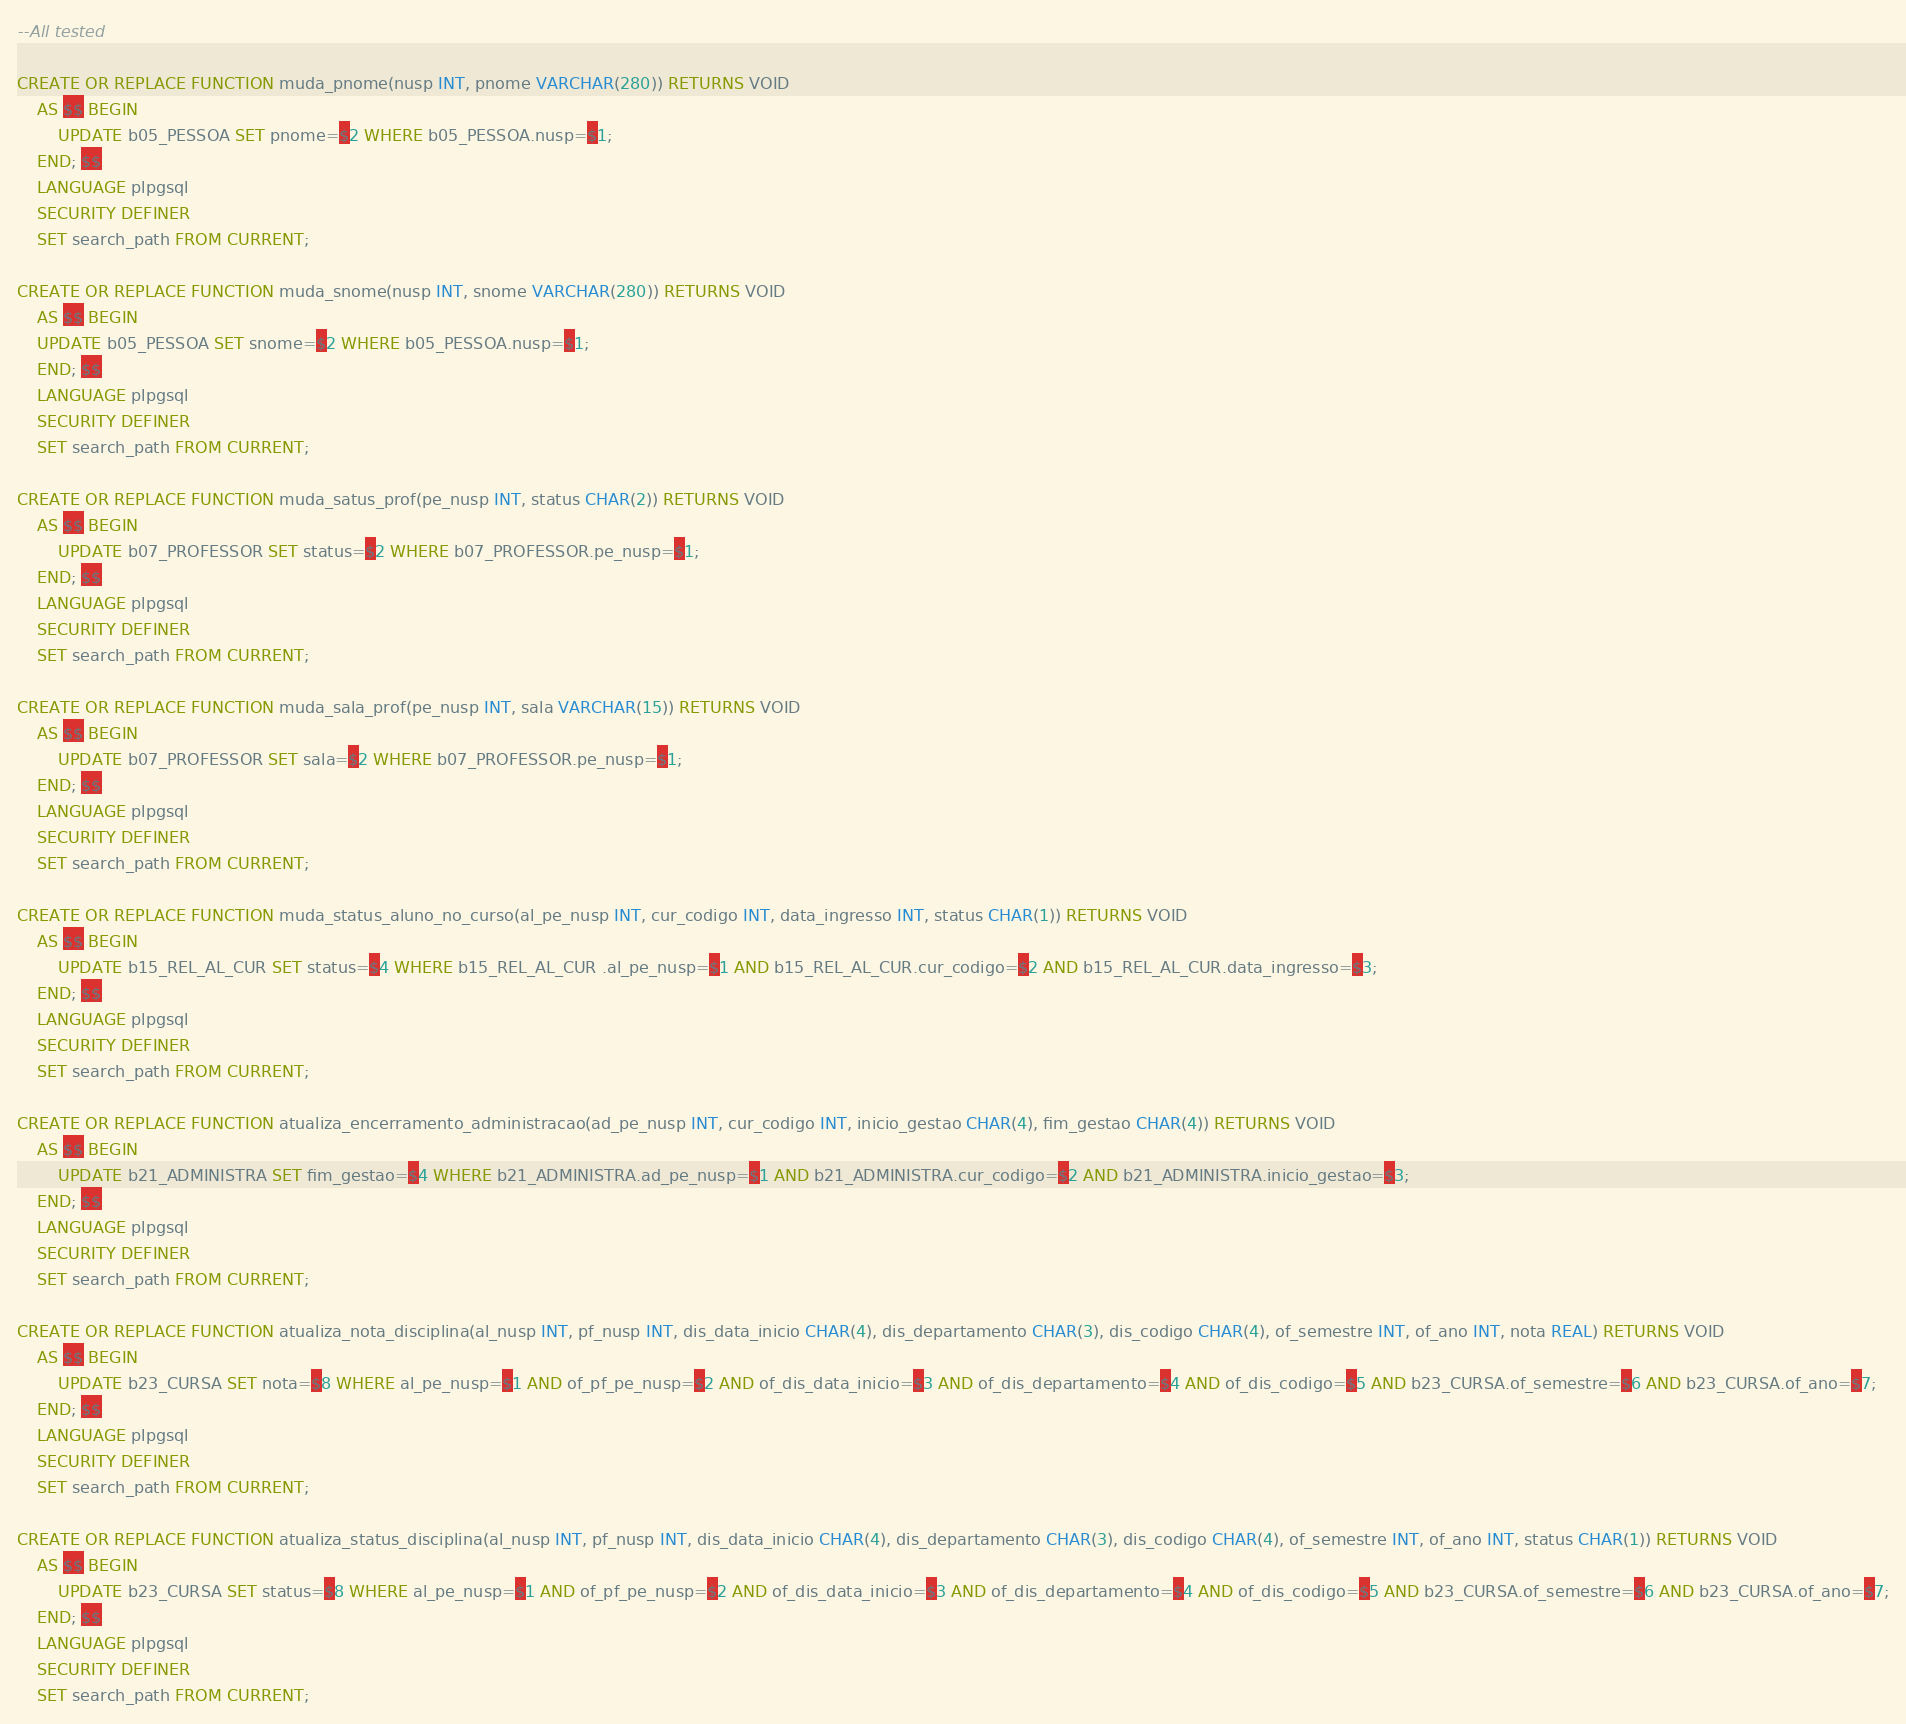Convert code to text. <code><loc_0><loc_0><loc_500><loc_500><_SQL_>--All tested

CREATE OR REPLACE FUNCTION muda_pnome(nusp INT, pnome VARCHAR(280)) RETURNS VOID
    AS $$ BEGIN
        UPDATE b05_PESSOA SET pnome=$2 WHERE b05_PESSOA.nusp=$1;
    END; $$
    LANGUAGE plpgsql
    SECURITY DEFINER
    SET search_path FROM CURRENT;

CREATE OR REPLACE FUNCTION muda_snome(nusp INT, snome VARCHAR(280)) RETURNS VOID
    AS $$ BEGIN
    UPDATE b05_PESSOA SET snome=$2 WHERE b05_PESSOA.nusp=$1;
    END; $$
    LANGUAGE plpgsql
    SECURITY DEFINER
    SET search_path FROM CURRENT;

CREATE OR REPLACE FUNCTION muda_satus_prof(pe_nusp INT, status CHAR(2)) RETURNS VOID
    AS $$ BEGIN
        UPDATE b07_PROFESSOR SET status=$2 WHERE b07_PROFESSOR.pe_nusp=$1;
    END; $$
    LANGUAGE plpgsql
    SECURITY DEFINER
    SET search_path FROM CURRENT;

CREATE OR REPLACE FUNCTION muda_sala_prof(pe_nusp INT, sala VARCHAR(15)) RETURNS VOID
    AS $$ BEGIN
        UPDATE b07_PROFESSOR SET sala=$2 WHERE b07_PROFESSOR.pe_nusp=$1;
    END; $$
    LANGUAGE plpgsql
    SECURITY DEFINER
    SET search_path FROM CURRENT;

CREATE OR REPLACE FUNCTION muda_status_aluno_no_curso(al_pe_nusp INT, cur_codigo INT, data_ingresso INT, status CHAR(1)) RETURNS VOID
    AS $$ BEGIN
        UPDATE b15_REL_AL_CUR SET status=$4 WHERE b15_REL_AL_CUR .al_pe_nusp=$1 AND b15_REL_AL_CUR.cur_codigo=$2 AND b15_REL_AL_CUR.data_ingresso=$3;
    END; $$
    LANGUAGE plpgsql
    SECURITY DEFINER
    SET search_path FROM CURRENT;

CREATE OR REPLACE FUNCTION atualiza_encerramento_administracao(ad_pe_nusp INT, cur_codigo INT, inicio_gestao CHAR(4), fim_gestao CHAR(4)) RETURNS VOID
    AS $$ BEGIN
        UPDATE b21_ADMINISTRA SET fim_gestao=$4 WHERE b21_ADMINISTRA.ad_pe_nusp=$1 AND b21_ADMINISTRA.cur_codigo=$2 AND b21_ADMINISTRA.inicio_gestao=$3;
    END; $$
    LANGUAGE plpgsql
    SECURITY DEFINER
    SET search_path FROM CURRENT;

CREATE OR REPLACE FUNCTION atualiza_nota_disciplina(al_nusp INT, pf_nusp INT, dis_data_inicio CHAR(4), dis_departamento CHAR(3), dis_codigo CHAR(4), of_semestre INT, of_ano INT, nota REAL) RETURNS VOID
    AS $$ BEGIN
        UPDATE b23_CURSA SET nota=$8 WHERE al_pe_nusp=$1 AND of_pf_pe_nusp=$2 AND of_dis_data_inicio=$3 AND of_dis_departamento=$4 AND of_dis_codigo=$5 AND b23_CURSA.of_semestre=$6 AND b23_CURSA.of_ano=$7;
    END; $$
    LANGUAGE plpgsql
    SECURITY DEFINER
    SET search_path FROM CURRENT;

CREATE OR REPLACE FUNCTION atualiza_status_disciplina(al_nusp INT, pf_nusp INT, dis_data_inicio CHAR(4), dis_departamento CHAR(3), dis_codigo CHAR(4), of_semestre INT, of_ano INT, status CHAR(1)) RETURNS VOID
    AS $$ BEGIN
        UPDATE b23_CURSA SET status=$8 WHERE al_pe_nusp=$1 AND of_pf_pe_nusp=$2 AND of_dis_data_inicio=$3 AND of_dis_departamento=$4 AND of_dis_codigo=$5 AND b23_CURSA.of_semestre=$6 AND b23_CURSA.of_ano=$7;
    END; $$
    LANGUAGE plpgsql
    SECURITY DEFINER
    SET search_path FROM CURRENT;</code> 